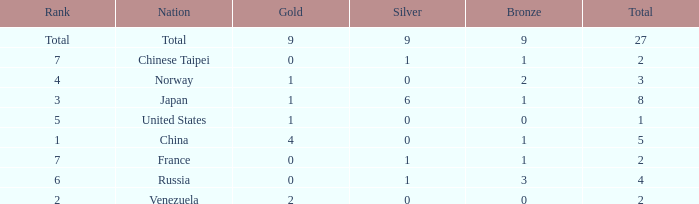What is the average Bronze for rank 3 and total is more than 8? None. Would you be able to parse every entry in this table? {'header': ['Rank', 'Nation', 'Gold', 'Silver', 'Bronze', 'Total'], 'rows': [['Total', 'Total', '9', '9', '9', '27'], ['7', 'Chinese Taipei', '0', '1', '1', '2'], ['4', 'Norway', '1', '0', '2', '3'], ['3', 'Japan', '1', '6', '1', '8'], ['5', 'United States', '1', '0', '0', '1'], ['1', 'China', '4', '0', '1', '5'], ['7', 'France', '0', '1', '1', '2'], ['6', 'Russia', '0', '1', '3', '4'], ['2', 'Venezuela', '2', '0', '0', '2']]} 